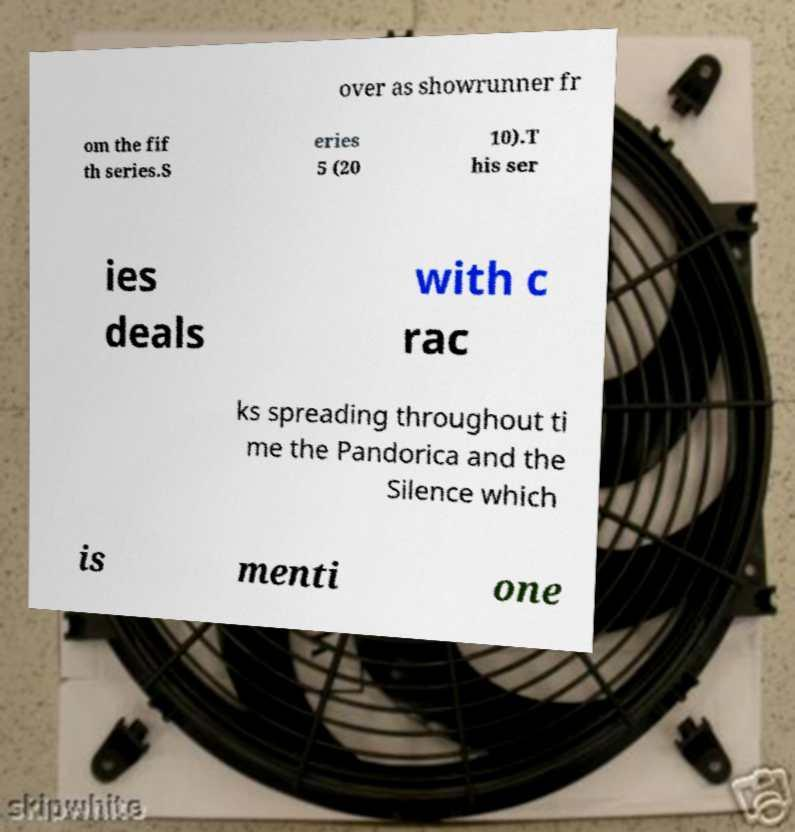Could you extract and type out the text from this image? over as showrunner fr om the fif th series.S eries 5 (20 10).T his ser ies deals with c rac ks spreading throughout ti me the Pandorica and the Silence which is menti one 